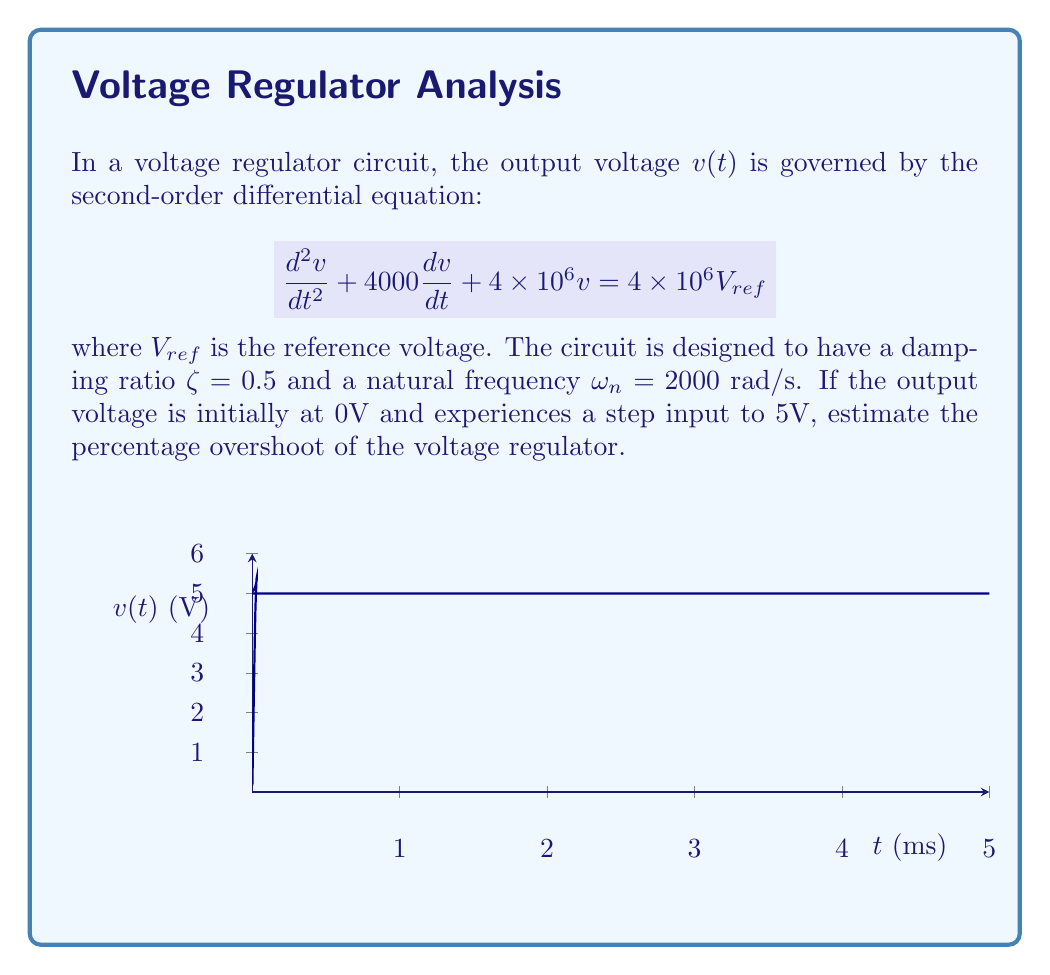Can you answer this question? To solve this problem, we'll follow these steps:

1) First, we need to confirm that the given differential equation matches the standard form for a second-order system:

   $$\frac{d^2v}{dt^2} + 2\zeta\omega_n\frac{dv}{dt} + \omega_n^2v = \omega_n^2V_{ref}$$

2) Comparing the coefficients:
   
   $2\zeta\omega_n = 4000$
   $\omega_n^2 = 4\times10^6$

3) We can verify that $\omega_n = 2000$ rad/s as given:

   $\sqrt{4\times10^6} = 2000$ rad/s

4) And we can confirm $\zeta = 0.5$:

   $\frac{4000}{2(2000)} = 0.5$

5) For a second-order system, the percentage overshoot (PO) is given by:

   $$PO = 100 \cdot e^{-\frac{\zeta\pi}{\sqrt{1-\zeta^2}}}$$

6) Substituting $\zeta = 0.5$:

   $$PO = 100 \cdot e^{-\frac{0.5\pi}{\sqrt{1-0.5^2}}}$$

7) Simplifying:

   $$PO = 100 \cdot e^{-\frac{0.5\pi}{\sqrt{0.75}}} \approx 16.3\%$$

Thus, the voltage regulator circuit is expected to have an overshoot of approximately 16.3%.
Answer: 16.3% 